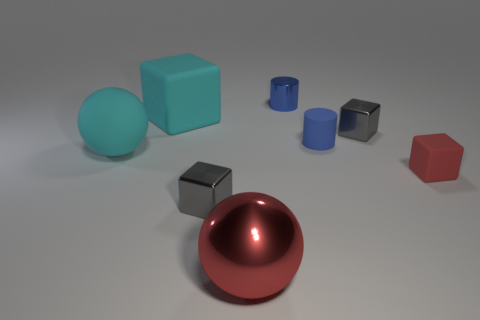There is a blue metallic thing that is the same shape as the small blue rubber object; what size is it?
Offer a very short reply. Small. Is there a cyan ball of the same size as the blue matte thing?
Make the answer very short. No. How many objects are tiny blue shiny things or large blue rubber cubes?
Provide a short and direct response. 1. There is a red thing that is behind the big metallic ball; does it have the same size as the ball behind the big shiny object?
Offer a terse response. No. Is there a cyan matte thing that has the same shape as the red metallic object?
Provide a succinct answer. Yes. Is the number of cyan objects in front of the small red thing less than the number of blue things?
Keep it short and to the point. Yes. Is the shape of the red shiny thing the same as the small blue rubber object?
Your answer should be very brief. No. There is a red thing on the left side of the tiny red rubber block; what size is it?
Ensure brevity in your answer.  Large. There is a blue object that is the same material as the cyan cube; what size is it?
Provide a succinct answer. Small. Is the number of tiny blue rubber cylinders less than the number of small purple rubber cylinders?
Ensure brevity in your answer.  No. 